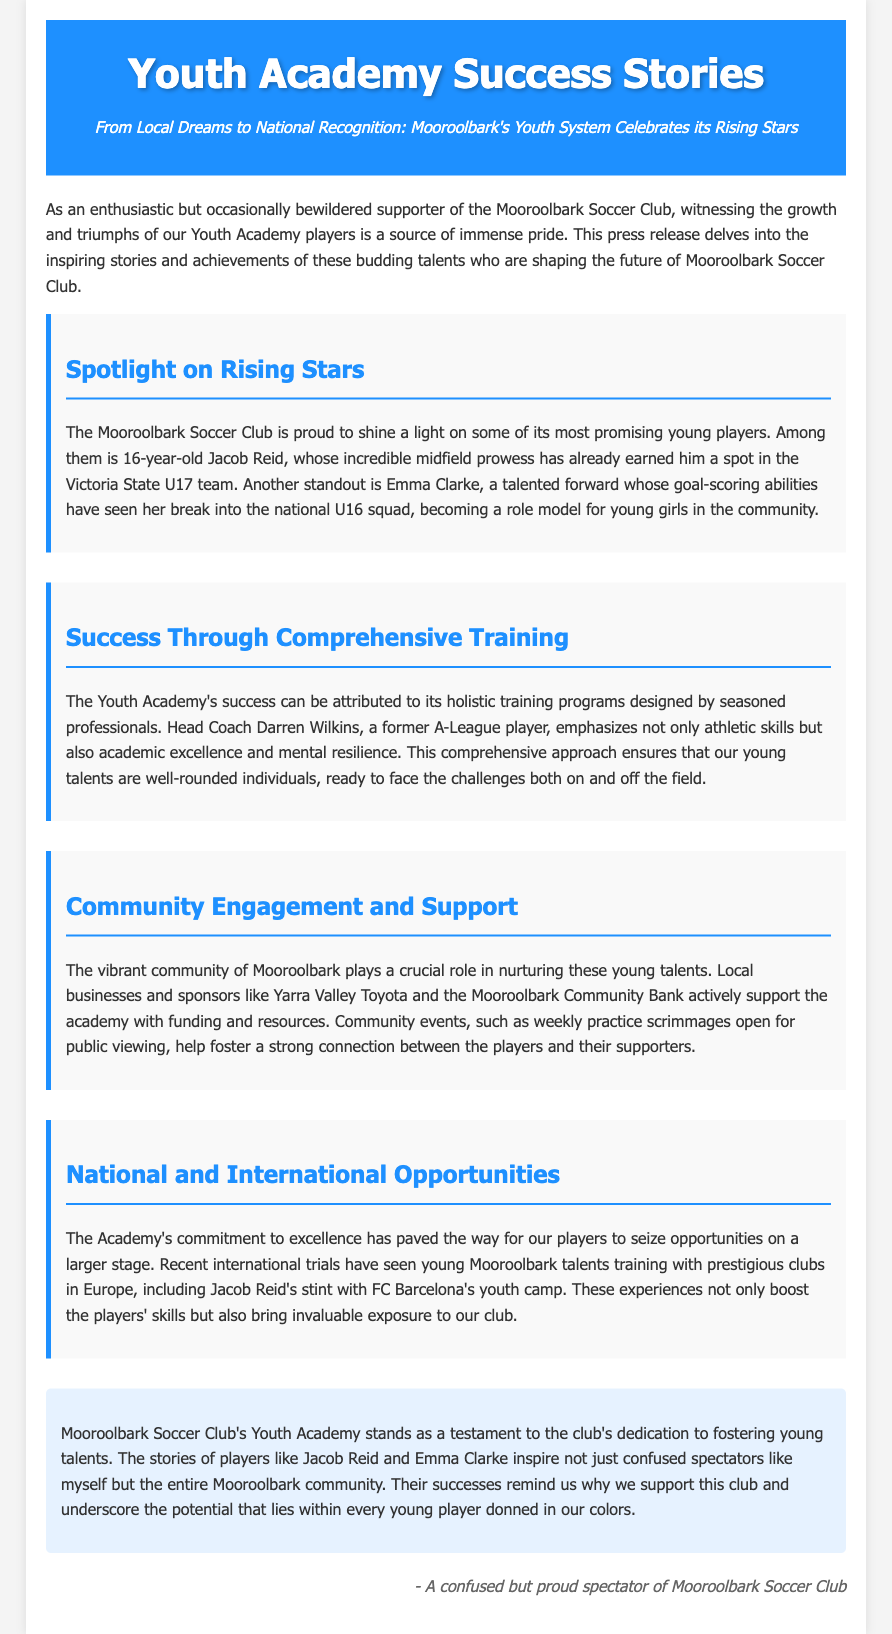What is the age of Jacob Reid? Jacob Reid is mentioned as a 16-year-old player in the document.
Answer: 16 Who is the Head Coach of the Youth Academy? The document states that Darren Wilkins is the Head Coach of the Youth Academy.
Answer: Darren Wilkins Which team has Emma Clarke broken into? Emma Clarke has broken into the national U16 squad, as noted in the document.
Answer: national U16 squad What club's youth camp did Jacob Reid train with? The document mentions that Jacob Reid had a stint with FC Barcelona's youth camp.
Answer: FC Barcelona What is emphasized in the academy's training programs? The training programs emphasize athletic skills, academic excellence, and mental resilience, as detailed in the document.
Answer: holistic training Who provides support to the Mooroolbark Youth Academy? Local businesses and sponsors, such as Yarra Valley Toyota and the Mooroolbark Community Bank, support the Youth Academy.
Answer: Yarra Valley Toyota, Mooroolbark Community Bank What type of events are open for public viewing? The document specifies that practice scrimmages are open for public viewing.
Answer: practice scrimmages What does the Youth Academy aim to build in its players? The Academy aims to build well-rounded individuals ready to face challenges.
Answer: well-rounded individuals 